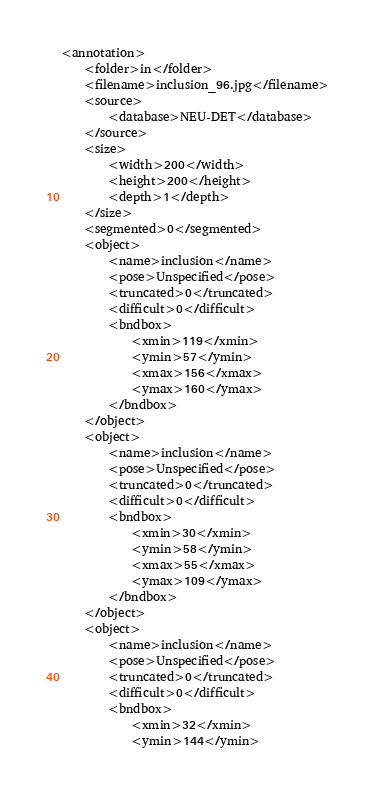<code> <loc_0><loc_0><loc_500><loc_500><_XML_><annotation>
	<folder>in</folder>
	<filename>inclusion_96.jpg</filename>
	<source>
		<database>NEU-DET</database>
	</source>
	<size>
		<width>200</width>
		<height>200</height>
		<depth>1</depth>
	</size>
	<segmented>0</segmented>
	<object>
		<name>inclusion</name>
		<pose>Unspecified</pose>
		<truncated>0</truncated>
		<difficult>0</difficult>
		<bndbox>
			<xmin>119</xmin>
			<ymin>57</ymin>
			<xmax>156</xmax>
			<ymax>160</ymax>
		</bndbox>
	</object>
	<object>
		<name>inclusion</name>
		<pose>Unspecified</pose>
		<truncated>0</truncated>
		<difficult>0</difficult>
		<bndbox>
			<xmin>30</xmin>
			<ymin>58</ymin>
			<xmax>55</xmax>
			<ymax>109</ymax>
		</bndbox>
	</object>
	<object>
		<name>inclusion</name>
		<pose>Unspecified</pose>
		<truncated>0</truncated>
		<difficult>0</difficult>
		<bndbox>
			<xmin>32</xmin>
			<ymin>144</ymin></code> 